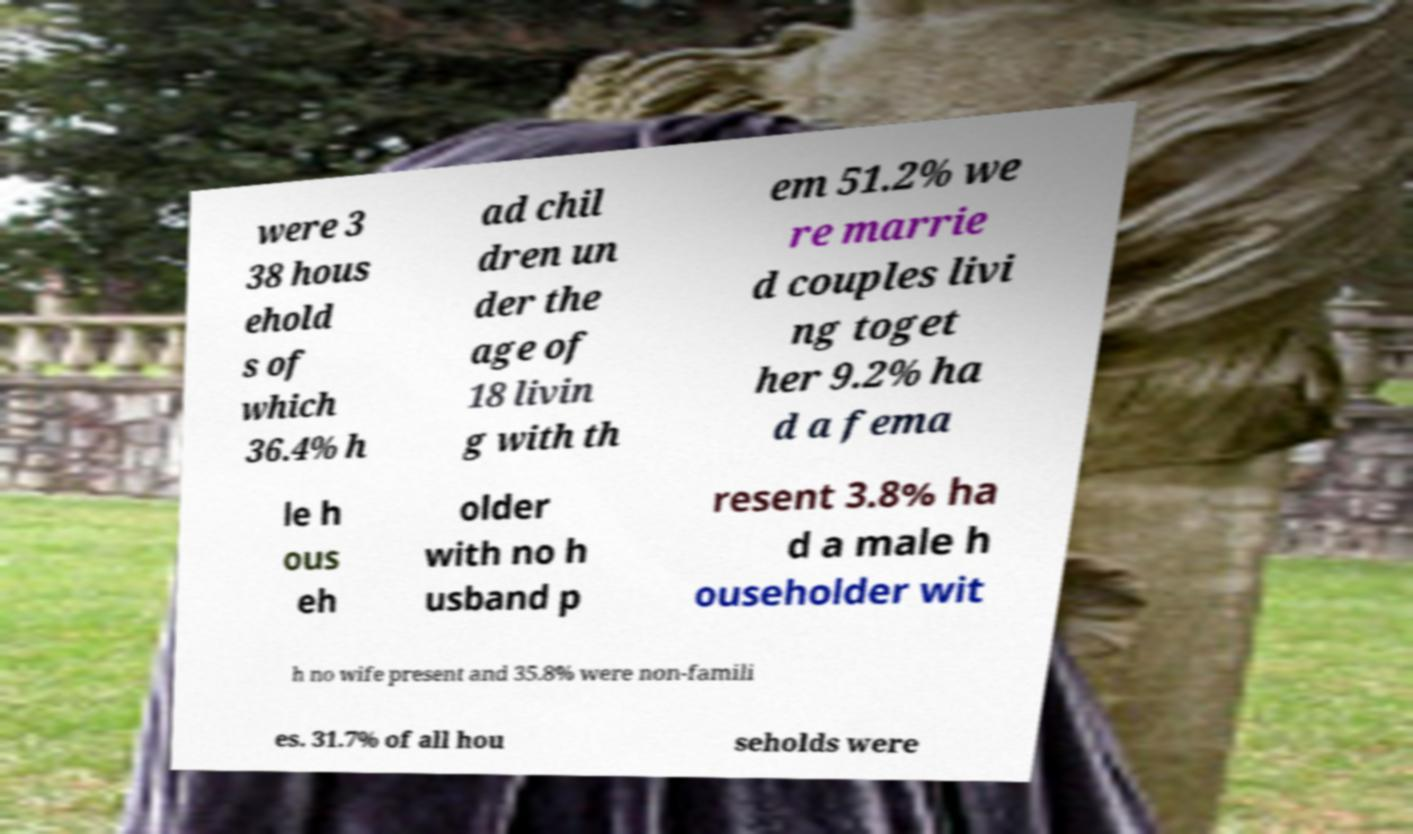There's text embedded in this image that I need extracted. Can you transcribe it verbatim? were 3 38 hous ehold s of which 36.4% h ad chil dren un der the age of 18 livin g with th em 51.2% we re marrie d couples livi ng toget her 9.2% ha d a fema le h ous eh older with no h usband p resent 3.8% ha d a male h ouseholder wit h no wife present and 35.8% were non-famili es. 31.7% of all hou seholds were 